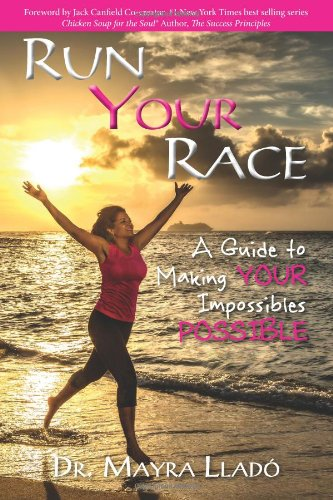Is this book related to Literature & Fiction? No, this book does not fall under the Literature & Fiction genre. It is primarily a Self-Help book aimed at inspiring and instructing on personal achievement. 